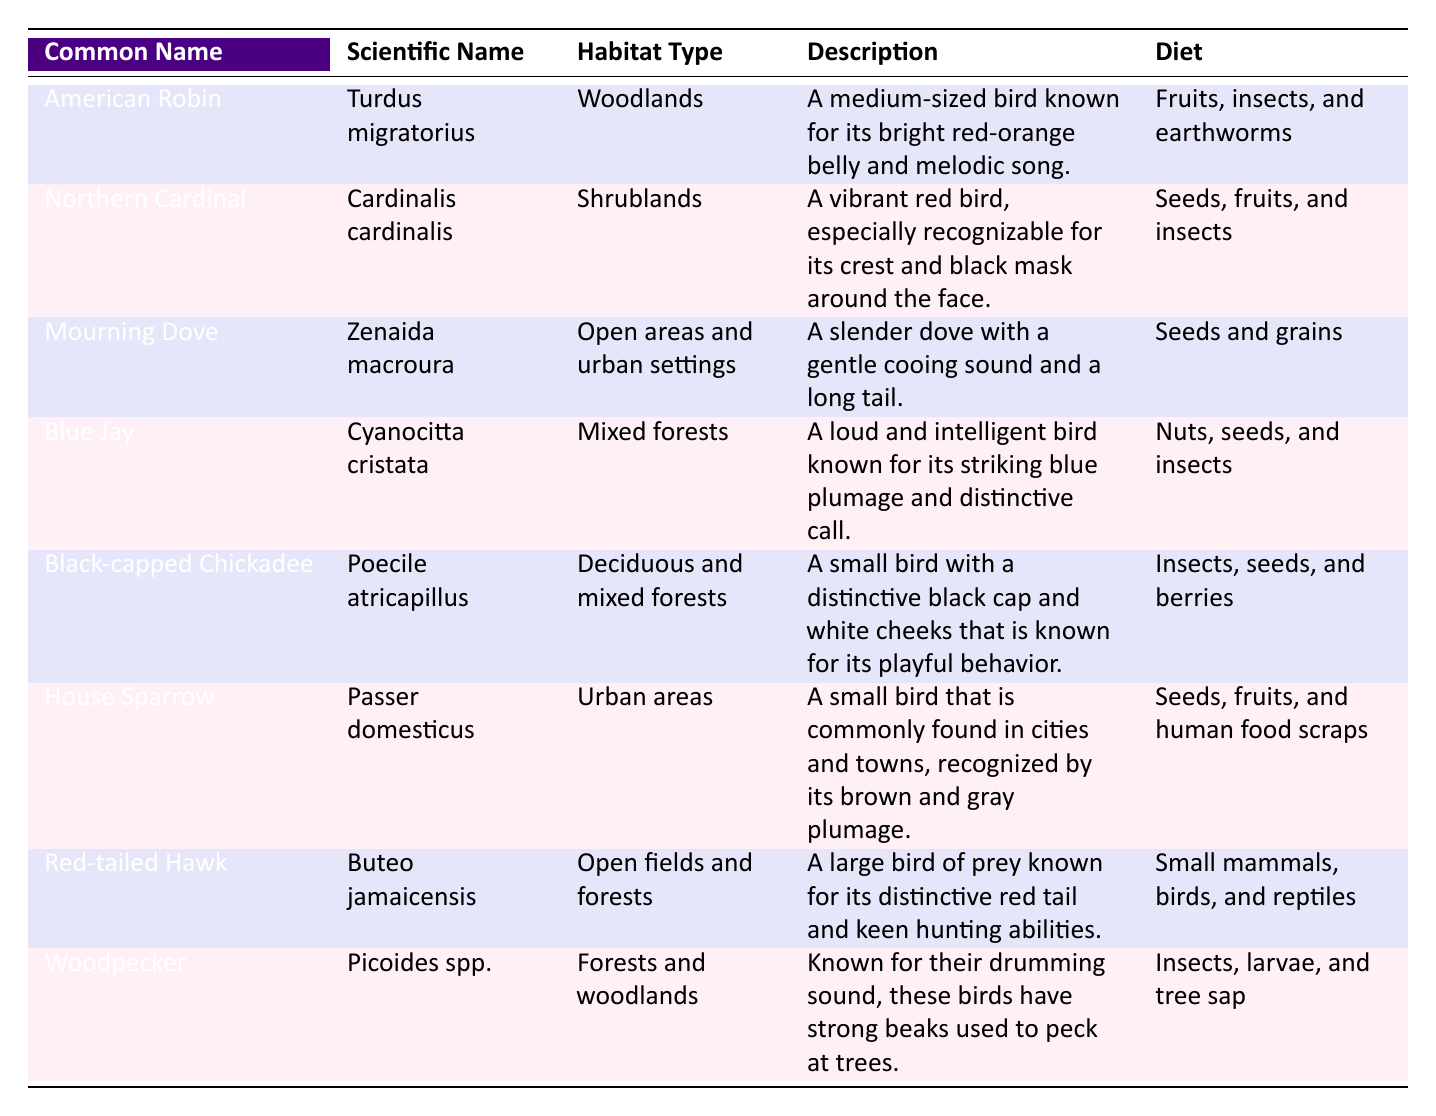What is the habitat type of the American Robin? The American Robin is listed under the habitat type "Woodlands" in the table under the relevant row.
Answer: Woodlands Which bird has the scientific name Cardinalis cardinalis? By locating the row corresponding to the "Northern Cardinal," we see that its scientific name is explicitly stated as "Cardinalis cardinalis."
Answer: Northern Cardinal Is the Black-capped Chickadee found in urban areas? The table does not indicate that the Black-capped Chickadee is found in urban areas; instead, it is mentioned under "Deciduous and mixed forests."
Answer: No Which bird has the broadest diet mentioned in the table? The diets for all birds in the table can be compared. The House Sparrow has a varied diet that includes seeds, fruits, and human food scraps, which encompasses multiple food types compared to others.
Answer: House Sparrow How many birds are associated with open areas as their habitat? The table shows that both the Mourning Dove and Red-tailed Hawk are located in the "Open areas and urban settings" and "Open fields and forests," respectively. Thus, this counts as two birds.
Answer: 2 Is the Blue Jay's diet primarily seeds? The Blue Jay's diet is mentioned as "Nuts, seeds, and insects," indicating that while seeds are part of its diet, it is not primarily seeds alone.
Answer: No What common name corresponds to the scientific name Picoides spp.? The row corresponding to the scientific name "Picoides spp." indicates that the common name is "Woodpecker."
Answer: Woodpecker Which bird has the longest description? By comparing the descriptions provided for each bird, the Red-tailed Hawk has a longer description (over 30 words), emphasizing its characteristics and hunting abilities, compared to others.
Answer: Red-tailed Hawk How many birds are known for their colorful appearance? The Northern Cardinal and Blue Jay are mentioned as vibrant and colorful birds, which are identified under the descriptions, leading to a total of two colorful birds.
Answer: 2 